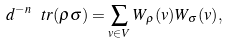<formula> <loc_0><loc_0><loc_500><loc_500>d ^ { - n } \, \ t r ( \rho \sigma ) = \sum _ { v \in V } W _ { \rho } ( v ) W _ { \sigma } ( v ) ,</formula> 